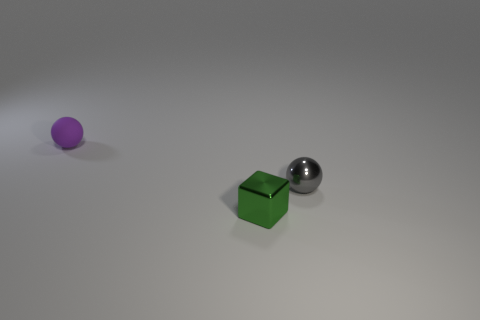Add 2 shiny balls. How many objects exist? 5 Subtract all balls. How many objects are left? 1 Subtract 1 gray spheres. How many objects are left? 2 Subtract all balls. Subtract all tiny brown cubes. How many objects are left? 1 Add 3 purple balls. How many purple balls are left? 4 Add 1 small cyan objects. How many small cyan objects exist? 1 